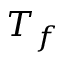<formula> <loc_0><loc_0><loc_500><loc_500>T _ { f }</formula> 